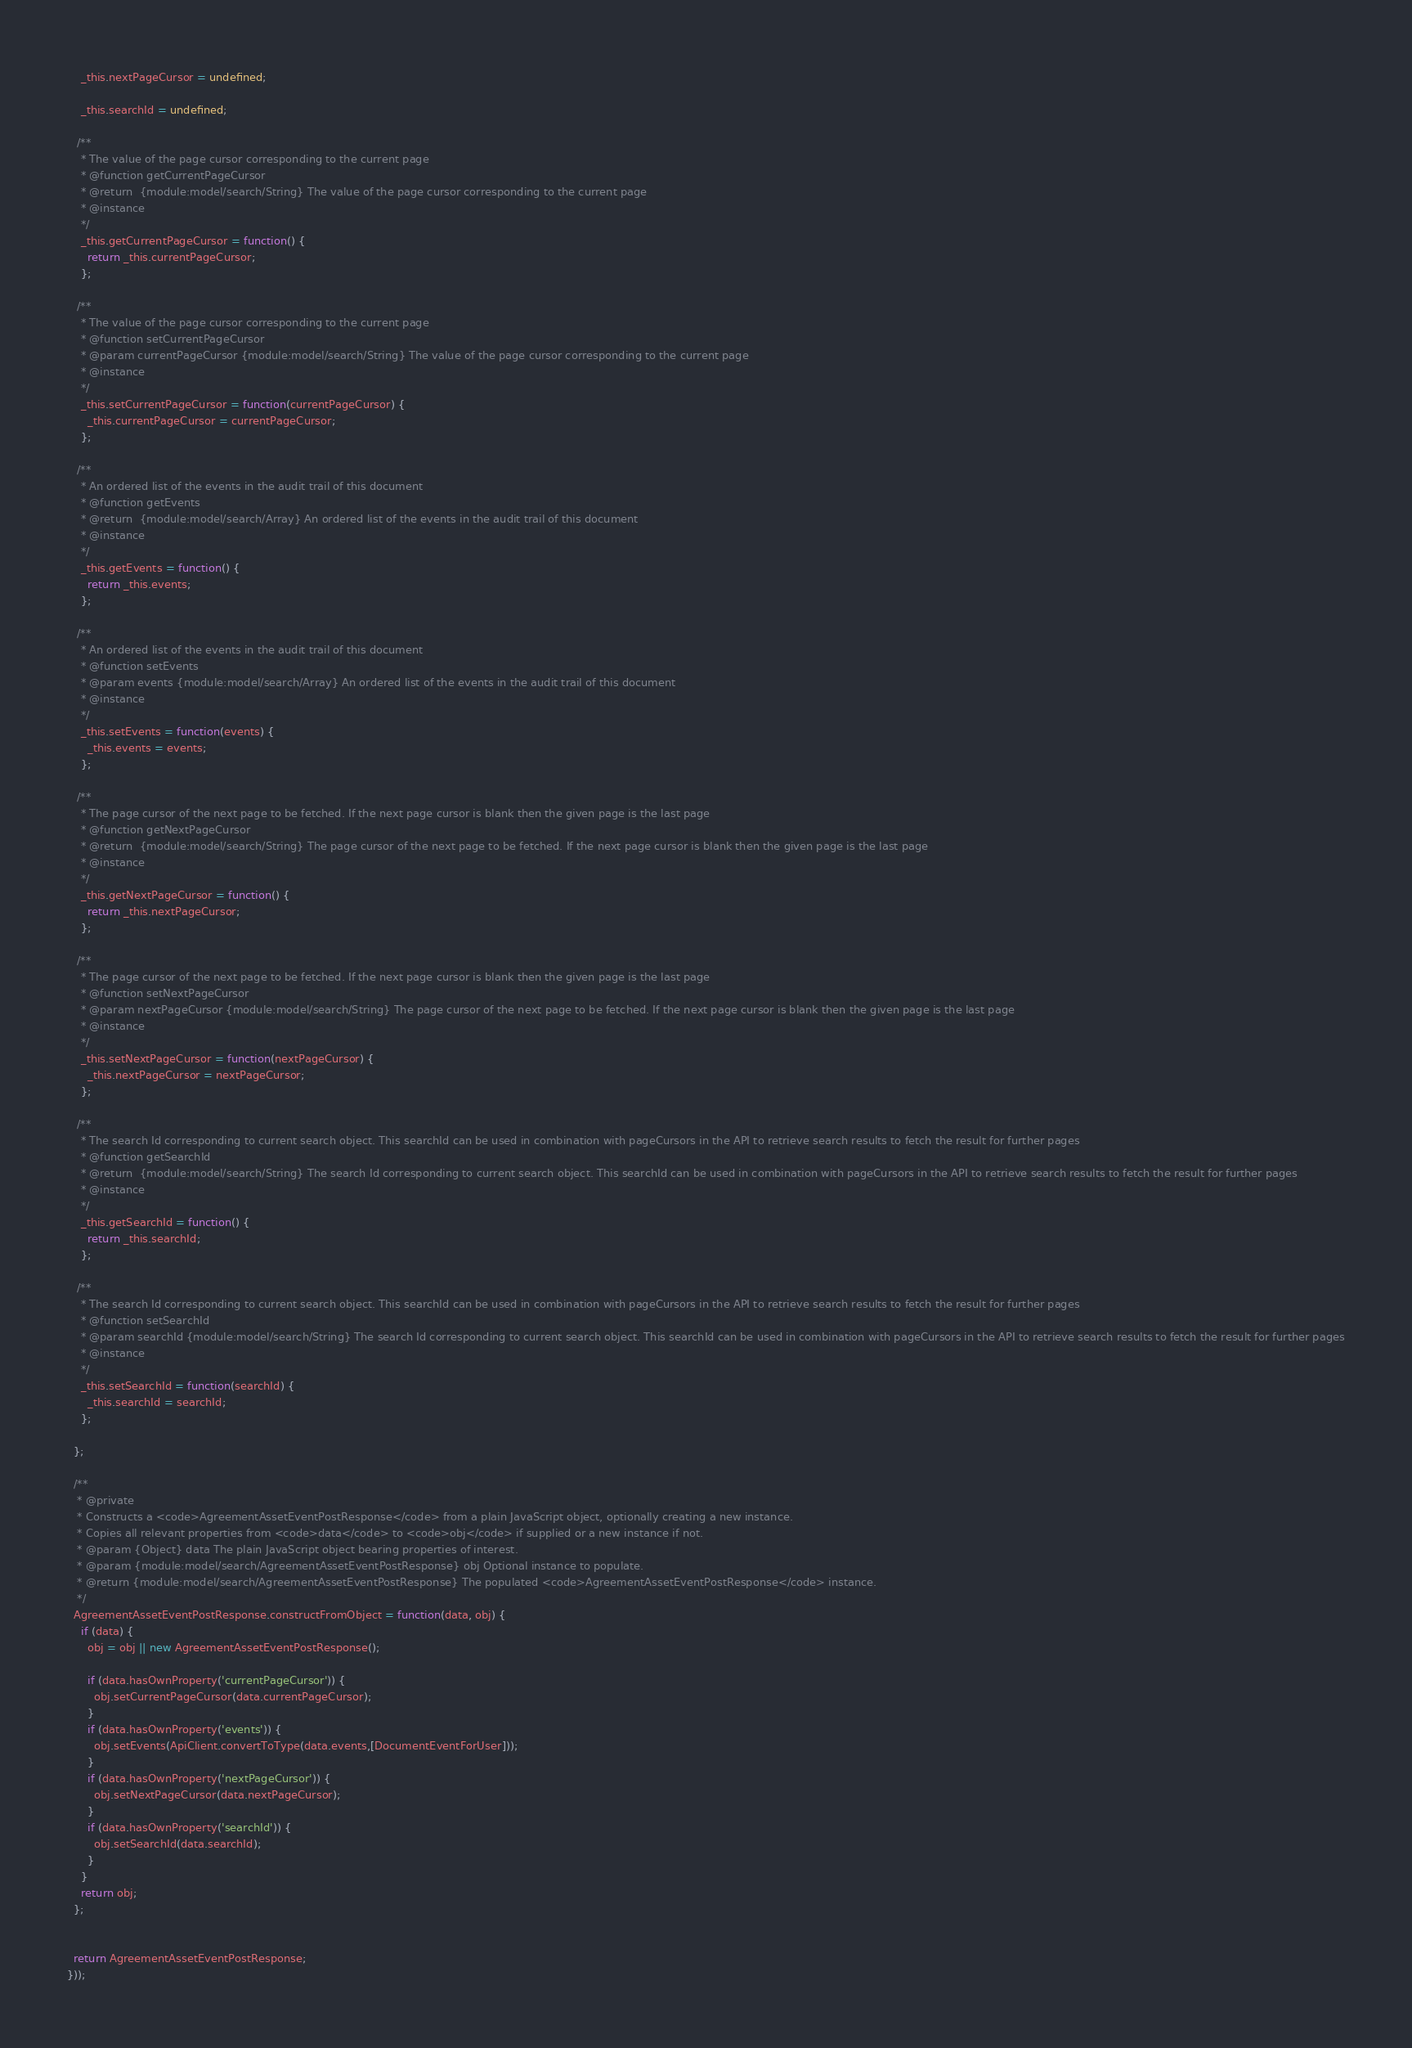Convert code to text. <code><loc_0><loc_0><loc_500><loc_500><_JavaScript_>    _this.nextPageCursor = undefined;

    _this.searchId = undefined;

   /**
    * The value of the page cursor corresponding to the current page
    * @function getCurrentPageCursor
    * @return  {module:model/search/String} The value of the page cursor corresponding to the current page  
    * @instance
    */
    _this.getCurrentPageCursor = function() {
      return _this.currentPageCursor;
    };

   /**
    * The value of the page cursor corresponding to the current page
    * @function setCurrentPageCursor
    * @param currentPageCursor {module:model/search/String} The value of the page cursor corresponding to the current page
    * @instance
    */
    _this.setCurrentPageCursor = function(currentPageCursor) {
      _this.currentPageCursor = currentPageCursor;
    };

   /**
    * An ordered list of the events in the audit trail of this document
    * @function getEvents
    * @return  {module:model/search/Array} An ordered list of the events in the audit trail of this document  
    * @instance
    */
    _this.getEvents = function() {
      return _this.events;
    };

   /**
    * An ordered list of the events in the audit trail of this document
    * @function setEvents
    * @param events {module:model/search/Array} An ordered list of the events in the audit trail of this document
    * @instance
    */
    _this.setEvents = function(events) {
      _this.events = events;
    };

   /**
    * The page cursor of the next page to be fetched. If the next page cursor is blank then the given page is the last page
    * @function getNextPageCursor
    * @return  {module:model/search/String} The page cursor of the next page to be fetched. If the next page cursor is blank then the given page is the last page  
    * @instance
    */
    _this.getNextPageCursor = function() {
      return _this.nextPageCursor;
    };

   /**
    * The page cursor of the next page to be fetched. If the next page cursor is blank then the given page is the last page
    * @function setNextPageCursor
    * @param nextPageCursor {module:model/search/String} The page cursor of the next page to be fetched. If the next page cursor is blank then the given page is the last page
    * @instance
    */
    _this.setNextPageCursor = function(nextPageCursor) {
      _this.nextPageCursor = nextPageCursor;
    };

   /**
    * The search Id corresponding to current search object. This searchId can be used in combination with pageCursors in the API to retrieve search results to fetch the result for further pages
    * @function getSearchId
    * @return  {module:model/search/String} The search Id corresponding to current search object. This searchId can be used in combination with pageCursors in the API to retrieve search results to fetch the result for further pages  
    * @instance
    */
    _this.getSearchId = function() {
      return _this.searchId;
    };

   /**
    * The search Id corresponding to current search object. This searchId can be used in combination with pageCursors in the API to retrieve search results to fetch the result for further pages
    * @function setSearchId
    * @param searchId {module:model/search/String} The search Id corresponding to current search object. This searchId can be used in combination with pageCursors in the API to retrieve search results to fetch the result for further pages
    * @instance
    */
    _this.setSearchId = function(searchId) {
      _this.searchId = searchId;
    };

  };

  /**
   * @private
   * Constructs a <code>AgreementAssetEventPostResponse</code> from a plain JavaScript object, optionally creating a new instance.
   * Copies all relevant properties from <code>data</code> to <code>obj</code> if supplied or a new instance if not.
   * @param {Object} data The plain JavaScript object bearing properties of interest.
   * @param {module:model/search/AgreementAssetEventPostResponse} obj Optional instance to populate.
   * @return {module:model/search/AgreementAssetEventPostResponse} The populated <code>AgreementAssetEventPostResponse</code> instance.
   */
  AgreementAssetEventPostResponse.constructFromObject = function(data, obj) {
    if (data) {
      obj = obj || new AgreementAssetEventPostResponse();

      if (data.hasOwnProperty('currentPageCursor')) {
        obj.setCurrentPageCursor(data.currentPageCursor);
      }
      if (data.hasOwnProperty('events')) {
        obj.setEvents(ApiClient.convertToType(data.events,[DocumentEventForUser]));
      }
      if (data.hasOwnProperty('nextPageCursor')) {
        obj.setNextPageCursor(data.nextPageCursor);
      }
      if (data.hasOwnProperty('searchId')) {
        obj.setSearchId(data.searchId);
      }
    }
    return obj;
  };


  return AgreementAssetEventPostResponse;
}));


</code> 